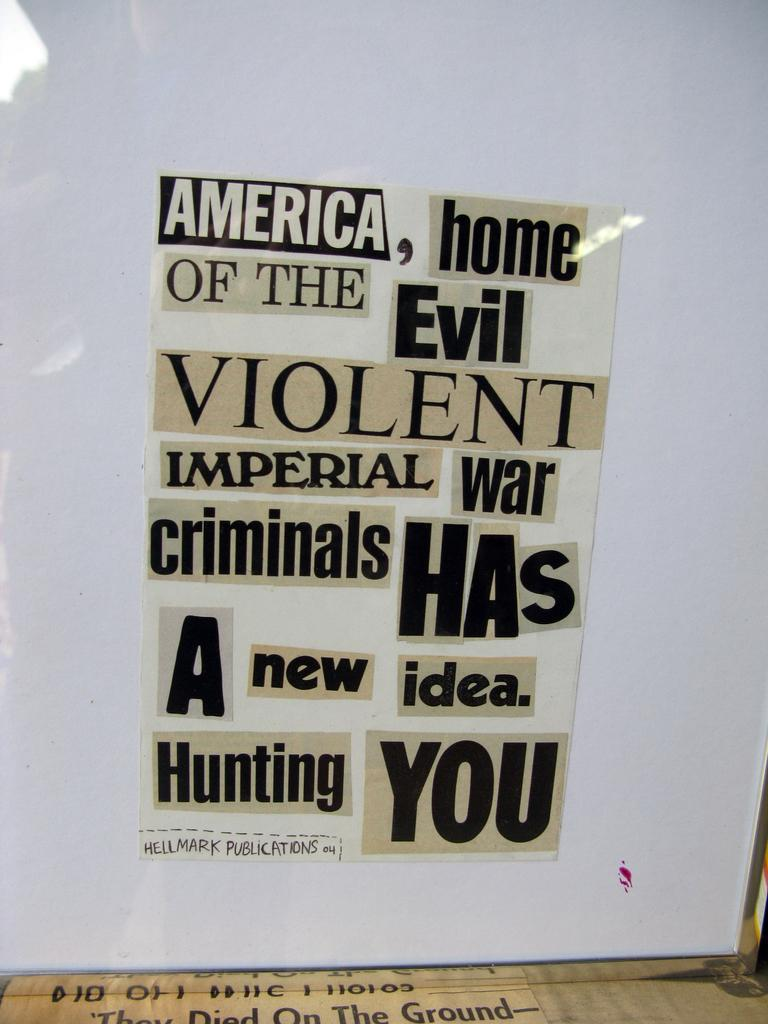<image>
Relay a brief, clear account of the picture shown. A collage of words that start with "America, home of the evil..." 